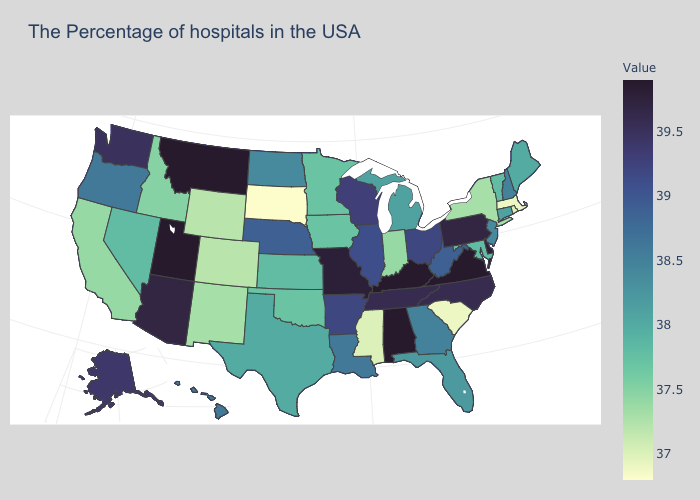Among the states that border Idaho , which have the lowest value?
Give a very brief answer. Wyoming. Does the map have missing data?
Be succinct. No. Does Georgia have a higher value than Virginia?
Short answer required. No. Is the legend a continuous bar?
Short answer required. Yes. Which states hav the highest value in the South?
Answer briefly. Virginia, Kentucky, Alabama. Which states have the highest value in the USA?
Write a very short answer. Virginia, Kentucky, Alabama, Utah, Montana. Does Utah have the highest value in the USA?
Be succinct. Yes. Does the map have missing data?
Concise answer only. No. 